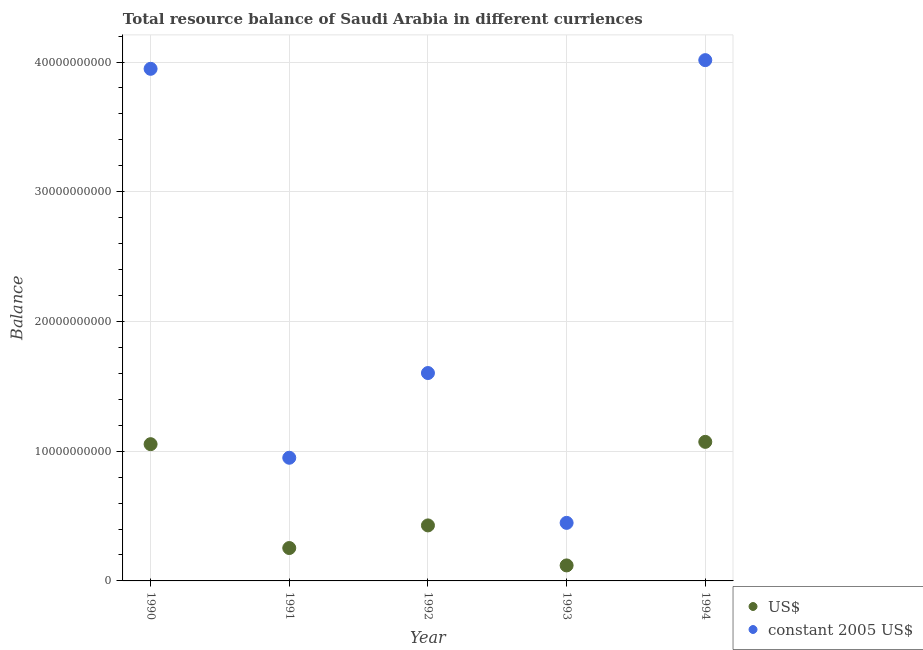How many different coloured dotlines are there?
Your response must be concise. 2. What is the resource balance in us$ in 1991?
Your answer should be very brief. 2.54e+09. Across all years, what is the maximum resource balance in constant us$?
Provide a succinct answer. 4.01e+1. Across all years, what is the minimum resource balance in constant us$?
Keep it short and to the point. 4.48e+09. In which year was the resource balance in constant us$ maximum?
Make the answer very short. 1994. In which year was the resource balance in us$ minimum?
Make the answer very short. 1993. What is the total resource balance in us$ in the graph?
Ensure brevity in your answer.  2.93e+1. What is the difference between the resource balance in constant us$ in 1991 and that in 1994?
Your answer should be compact. -3.07e+1. What is the difference between the resource balance in constant us$ in 1993 and the resource balance in us$ in 1990?
Give a very brief answer. -6.07e+09. What is the average resource balance in constant us$ per year?
Provide a short and direct response. 2.19e+1. In the year 1994, what is the difference between the resource balance in constant us$ and resource balance in us$?
Make the answer very short. 2.94e+1. In how many years, is the resource balance in constant us$ greater than 24000000000 units?
Your response must be concise. 2. What is the ratio of the resource balance in us$ in 1991 to that in 1993?
Your answer should be compact. 2.12. Is the resource balance in constant us$ in 1990 less than that in 1992?
Ensure brevity in your answer.  No. Is the difference between the resource balance in us$ in 1992 and 1993 greater than the difference between the resource balance in constant us$ in 1992 and 1993?
Ensure brevity in your answer.  No. What is the difference between the highest and the second highest resource balance in us$?
Provide a succinct answer. 1.79e+08. What is the difference between the highest and the lowest resource balance in us$?
Provide a succinct answer. 9.53e+09. In how many years, is the resource balance in us$ greater than the average resource balance in us$ taken over all years?
Your response must be concise. 2. Is the sum of the resource balance in constant us$ in 1990 and 1994 greater than the maximum resource balance in us$ across all years?
Offer a very short reply. Yes. Does the resource balance in us$ monotonically increase over the years?
Ensure brevity in your answer.  No. How many dotlines are there?
Your answer should be very brief. 2. How many years are there in the graph?
Offer a terse response. 5. What is the difference between two consecutive major ticks on the Y-axis?
Offer a terse response. 1.00e+1. Are the values on the major ticks of Y-axis written in scientific E-notation?
Make the answer very short. No. Where does the legend appear in the graph?
Your answer should be compact. Bottom right. How many legend labels are there?
Your answer should be very brief. 2. How are the legend labels stacked?
Offer a terse response. Vertical. What is the title of the graph?
Your answer should be very brief. Total resource balance of Saudi Arabia in different curriences. What is the label or title of the X-axis?
Keep it short and to the point. Year. What is the label or title of the Y-axis?
Provide a short and direct response. Balance. What is the Balance in US$ in 1990?
Your response must be concise. 1.05e+1. What is the Balance of constant 2005 US$ in 1990?
Give a very brief answer. 3.95e+1. What is the Balance of US$ in 1991?
Make the answer very short. 2.54e+09. What is the Balance of constant 2005 US$ in 1991?
Your response must be concise. 9.50e+09. What is the Balance of US$ in 1992?
Offer a very short reply. 4.28e+09. What is the Balance of constant 2005 US$ in 1992?
Give a very brief answer. 1.60e+1. What is the Balance in US$ in 1993?
Make the answer very short. 1.19e+09. What is the Balance of constant 2005 US$ in 1993?
Provide a succinct answer. 4.48e+09. What is the Balance in US$ in 1994?
Offer a very short reply. 1.07e+1. What is the Balance of constant 2005 US$ in 1994?
Make the answer very short. 4.01e+1. Across all years, what is the maximum Balance of US$?
Your answer should be compact. 1.07e+1. Across all years, what is the maximum Balance of constant 2005 US$?
Your answer should be very brief. 4.01e+1. Across all years, what is the minimum Balance of US$?
Give a very brief answer. 1.19e+09. Across all years, what is the minimum Balance in constant 2005 US$?
Give a very brief answer. 4.48e+09. What is the total Balance of US$ in the graph?
Provide a short and direct response. 2.93e+1. What is the total Balance in constant 2005 US$ in the graph?
Provide a short and direct response. 1.10e+11. What is the difference between the Balance in US$ in 1990 and that in 1991?
Offer a very short reply. 8.01e+09. What is the difference between the Balance in constant 2005 US$ in 1990 and that in 1991?
Give a very brief answer. 3.00e+1. What is the difference between the Balance of US$ in 1990 and that in 1992?
Keep it short and to the point. 6.26e+09. What is the difference between the Balance of constant 2005 US$ in 1990 and that in 1992?
Ensure brevity in your answer.  2.35e+1. What is the difference between the Balance of US$ in 1990 and that in 1993?
Your answer should be compact. 9.35e+09. What is the difference between the Balance in constant 2005 US$ in 1990 and that in 1993?
Your response must be concise. 3.50e+1. What is the difference between the Balance in US$ in 1990 and that in 1994?
Ensure brevity in your answer.  -1.79e+08. What is the difference between the Balance of constant 2005 US$ in 1990 and that in 1994?
Give a very brief answer. -6.69e+08. What is the difference between the Balance in US$ in 1991 and that in 1992?
Your answer should be compact. -1.74e+09. What is the difference between the Balance in constant 2005 US$ in 1991 and that in 1992?
Your answer should be very brief. -6.53e+09. What is the difference between the Balance of US$ in 1991 and that in 1993?
Provide a short and direct response. 1.34e+09. What is the difference between the Balance in constant 2005 US$ in 1991 and that in 1993?
Keep it short and to the point. 5.02e+09. What is the difference between the Balance of US$ in 1991 and that in 1994?
Give a very brief answer. -8.18e+09. What is the difference between the Balance in constant 2005 US$ in 1991 and that in 1994?
Your answer should be very brief. -3.07e+1. What is the difference between the Balance of US$ in 1992 and that in 1993?
Provide a succinct answer. 3.08e+09. What is the difference between the Balance in constant 2005 US$ in 1992 and that in 1993?
Offer a very short reply. 1.16e+1. What is the difference between the Balance of US$ in 1992 and that in 1994?
Your answer should be very brief. -6.44e+09. What is the difference between the Balance of constant 2005 US$ in 1992 and that in 1994?
Keep it short and to the point. -2.41e+1. What is the difference between the Balance in US$ in 1993 and that in 1994?
Keep it short and to the point. -9.53e+09. What is the difference between the Balance of constant 2005 US$ in 1993 and that in 1994?
Your response must be concise. -3.57e+1. What is the difference between the Balance of US$ in 1990 and the Balance of constant 2005 US$ in 1991?
Offer a very short reply. 1.05e+09. What is the difference between the Balance in US$ in 1990 and the Balance in constant 2005 US$ in 1992?
Give a very brief answer. -5.48e+09. What is the difference between the Balance in US$ in 1990 and the Balance in constant 2005 US$ in 1993?
Provide a succinct answer. 6.07e+09. What is the difference between the Balance in US$ in 1990 and the Balance in constant 2005 US$ in 1994?
Your answer should be very brief. -2.96e+1. What is the difference between the Balance of US$ in 1991 and the Balance of constant 2005 US$ in 1992?
Ensure brevity in your answer.  -1.35e+1. What is the difference between the Balance of US$ in 1991 and the Balance of constant 2005 US$ in 1993?
Make the answer very short. -1.94e+09. What is the difference between the Balance of US$ in 1991 and the Balance of constant 2005 US$ in 1994?
Make the answer very short. -3.76e+1. What is the difference between the Balance in US$ in 1992 and the Balance in constant 2005 US$ in 1993?
Your answer should be compact. -1.96e+08. What is the difference between the Balance in US$ in 1992 and the Balance in constant 2005 US$ in 1994?
Your response must be concise. -3.59e+1. What is the difference between the Balance in US$ in 1993 and the Balance in constant 2005 US$ in 1994?
Give a very brief answer. -3.90e+1. What is the average Balance in US$ per year?
Offer a very short reply. 5.85e+09. What is the average Balance of constant 2005 US$ per year?
Keep it short and to the point. 2.19e+1. In the year 1990, what is the difference between the Balance of US$ and Balance of constant 2005 US$?
Your answer should be very brief. -2.89e+1. In the year 1991, what is the difference between the Balance of US$ and Balance of constant 2005 US$?
Offer a terse response. -6.96e+09. In the year 1992, what is the difference between the Balance in US$ and Balance in constant 2005 US$?
Provide a short and direct response. -1.17e+1. In the year 1993, what is the difference between the Balance in US$ and Balance in constant 2005 US$?
Ensure brevity in your answer.  -3.28e+09. In the year 1994, what is the difference between the Balance of US$ and Balance of constant 2005 US$?
Provide a succinct answer. -2.94e+1. What is the ratio of the Balance in US$ in 1990 to that in 1991?
Your answer should be compact. 4.16. What is the ratio of the Balance of constant 2005 US$ in 1990 to that in 1991?
Offer a very short reply. 4.16. What is the ratio of the Balance of US$ in 1990 to that in 1992?
Offer a terse response. 2.46. What is the ratio of the Balance in constant 2005 US$ in 1990 to that in 1992?
Your answer should be compact. 2.46. What is the ratio of the Balance of US$ in 1990 to that in 1993?
Your answer should be very brief. 8.82. What is the ratio of the Balance in constant 2005 US$ in 1990 to that in 1993?
Make the answer very short. 8.82. What is the ratio of the Balance in US$ in 1990 to that in 1994?
Give a very brief answer. 0.98. What is the ratio of the Balance in constant 2005 US$ in 1990 to that in 1994?
Your answer should be compact. 0.98. What is the ratio of the Balance of US$ in 1991 to that in 1992?
Ensure brevity in your answer.  0.59. What is the ratio of the Balance of constant 2005 US$ in 1991 to that in 1992?
Provide a succinct answer. 0.59. What is the ratio of the Balance in US$ in 1991 to that in 1993?
Your response must be concise. 2.12. What is the ratio of the Balance in constant 2005 US$ in 1991 to that in 1993?
Provide a short and direct response. 2.12. What is the ratio of the Balance of US$ in 1991 to that in 1994?
Keep it short and to the point. 0.24. What is the ratio of the Balance in constant 2005 US$ in 1991 to that in 1994?
Provide a succinct answer. 0.24. What is the ratio of the Balance of US$ in 1992 to that in 1993?
Your answer should be very brief. 3.58. What is the ratio of the Balance of constant 2005 US$ in 1992 to that in 1993?
Your answer should be compact. 3.58. What is the ratio of the Balance in US$ in 1992 to that in 1994?
Offer a terse response. 0.4. What is the ratio of the Balance of constant 2005 US$ in 1992 to that in 1994?
Offer a very short reply. 0.4. What is the ratio of the Balance of US$ in 1993 to that in 1994?
Offer a terse response. 0.11. What is the ratio of the Balance in constant 2005 US$ in 1993 to that in 1994?
Your answer should be very brief. 0.11. What is the difference between the highest and the second highest Balance in US$?
Offer a terse response. 1.79e+08. What is the difference between the highest and the second highest Balance of constant 2005 US$?
Offer a very short reply. 6.69e+08. What is the difference between the highest and the lowest Balance of US$?
Ensure brevity in your answer.  9.53e+09. What is the difference between the highest and the lowest Balance in constant 2005 US$?
Provide a short and direct response. 3.57e+1. 